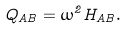<formula> <loc_0><loc_0><loc_500><loc_500>Q _ { A B } = \omega ^ { 2 } H _ { A B } .</formula> 